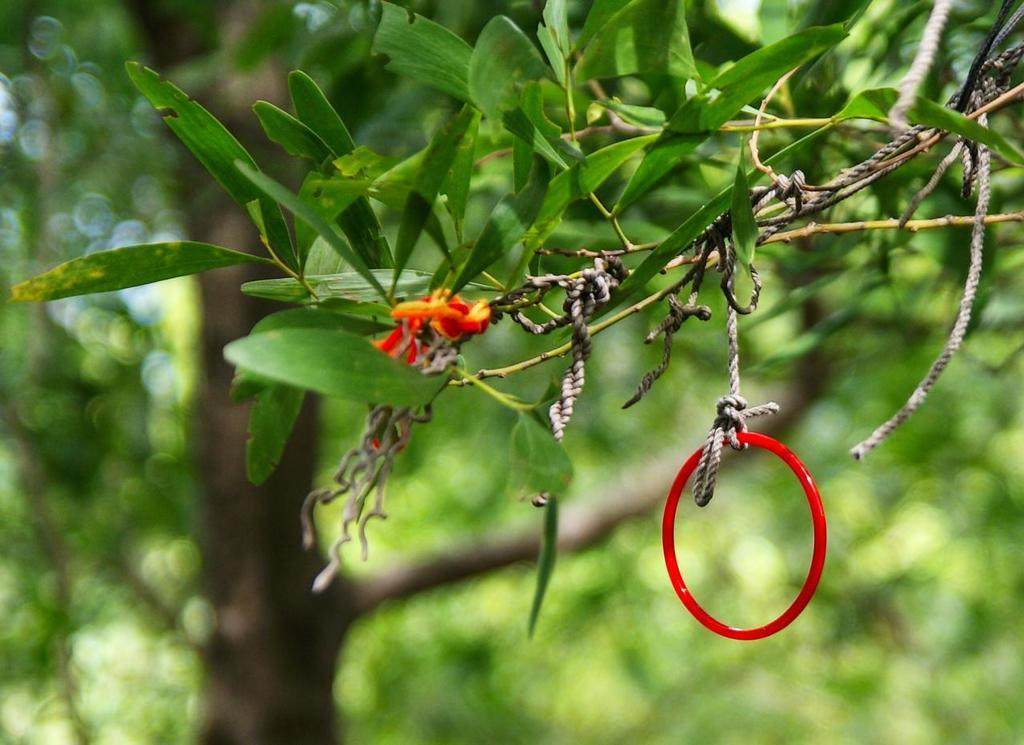What is the color of the bangle in the image? The bangle in the image is red. How is the bangle positioned in the image? The bangle is hanging from a plant. What is the plant tied to in the image? The plant is tied to a rope. What can be seen in the background of the image? There is a tree visible in the background of the image. How would you describe the overall clarity of the image? The image is slightly blurry at the back. Can you see any snakes slithering around the bangle in the image? There are no snakes visible in the image; it only features a red bangle hanging from a plant. What type of wrench is being used to tighten the rope in the image? There is no wrench present in the image; the plant is tied to a rope using a knot or other fastening method. 